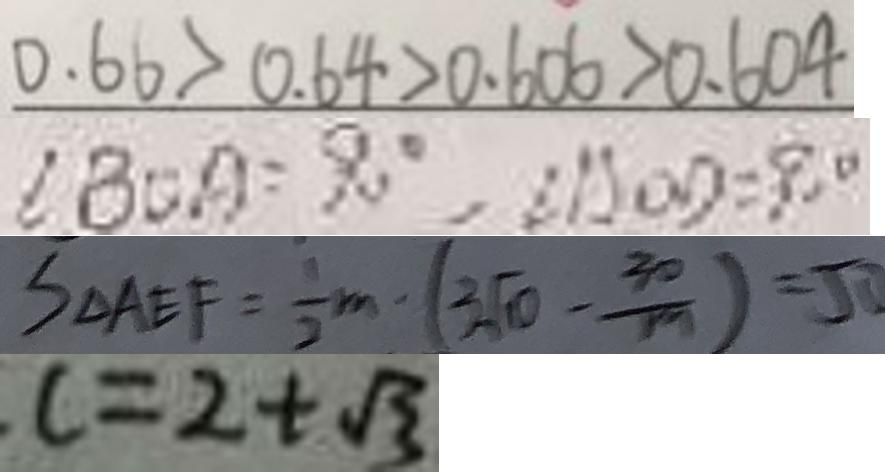Convert formula to latex. <formula><loc_0><loc_0><loc_500><loc_500>0 . 6 6 > 0 . 6 4 > 0 . 6 0 6 > 0 . 6 0 4 
 \angle B O A = 9 0 ^ { \circ } , \angle A O D = 9 0 ^ { \circ } 
 S _ { \Delta } A E F = \frac { 1 } { 2 } m \cdot ( 3 \sqrt { 1 0 } - \frac { 3 0 } { 1 9 } ) = 5 0 
 c = 2 + \sqrt { 3 }</formula> 